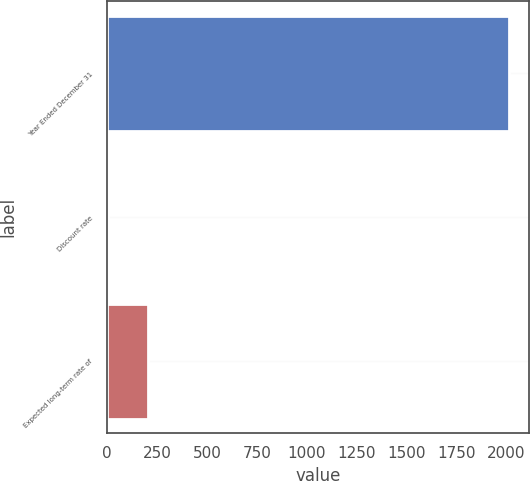Convert chart to OTSL. <chart><loc_0><loc_0><loc_500><loc_500><bar_chart><fcel>Year Ended December 31<fcel>Discount rate<fcel>Expected long-term rate of<nl><fcel>2014<fcel>4.75<fcel>205.68<nl></chart> 